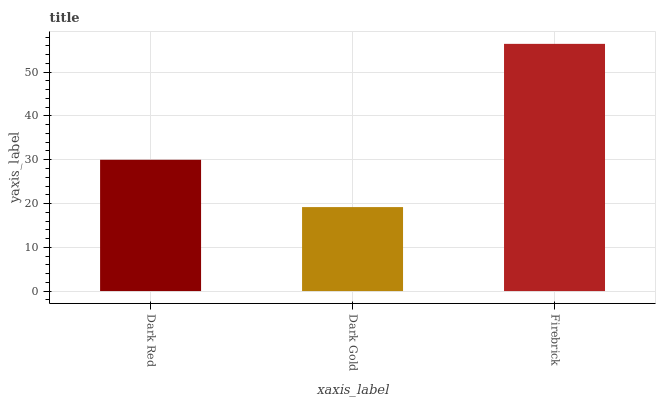Is Dark Gold the minimum?
Answer yes or no. Yes. Is Firebrick the maximum?
Answer yes or no. Yes. Is Firebrick the minimum?
Answer yes or no. No. Is Dark Gold the maximum?
Answer yes or no. No. Is Firebrick greater than Dark Gold?
Answer yes or no. Yes. Is Dark Gold less than Firebrick?
Answer yes or no. Yes. Is Dark Gold greater than Firebrick?
Answer yes or no. No. Is Firebrick less than Dark Gold?
Answer yes or no. No. Is Dark Red the high median?
Answer yes or no. Yes. Is Dark Red the low median?
Answer yes or no. Yes. Is Firebrick the high median?
Answer yes or no. No. Is Dark Gold the low median?
Answer yes or no. No. 